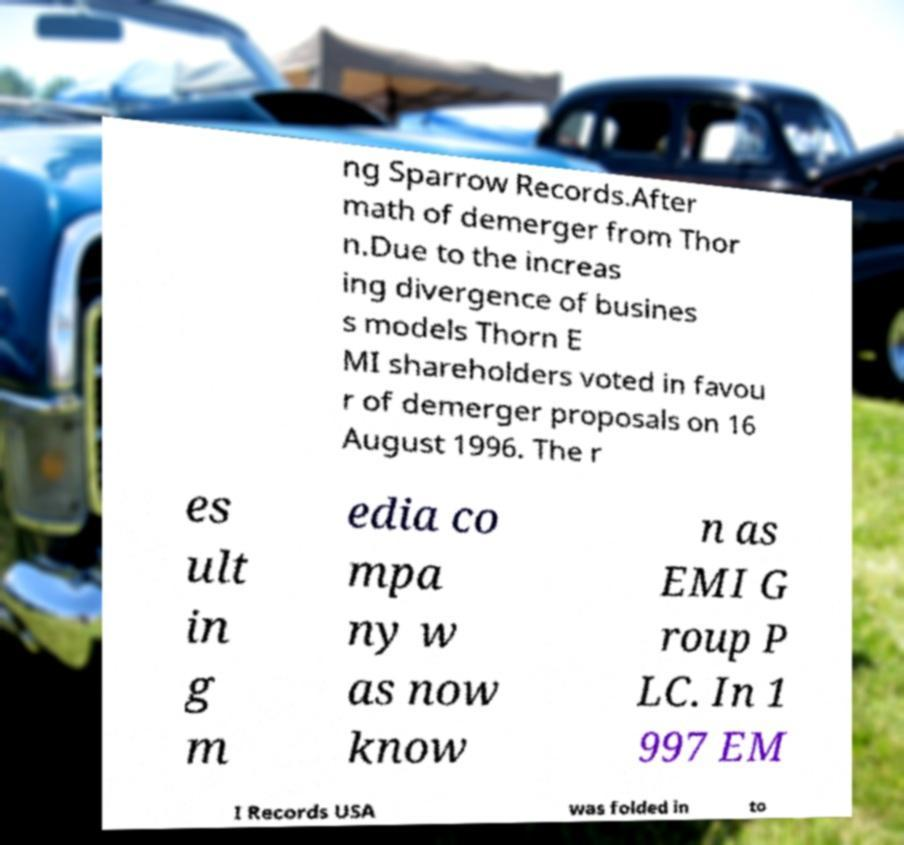Can you accurately transcribe the text from the provided image for me? ng Sparrow Records.After math of demerger from Thor n.Due to the increas ing divergence of busines s models Thorn E MI shareholders voted in favou r of demerger proposals on 16 August 1996. The r es ult in g m edia co mpa ny w as now know n as EMI G roup P LC. In 1 997 EM I Records USA was folded in to 